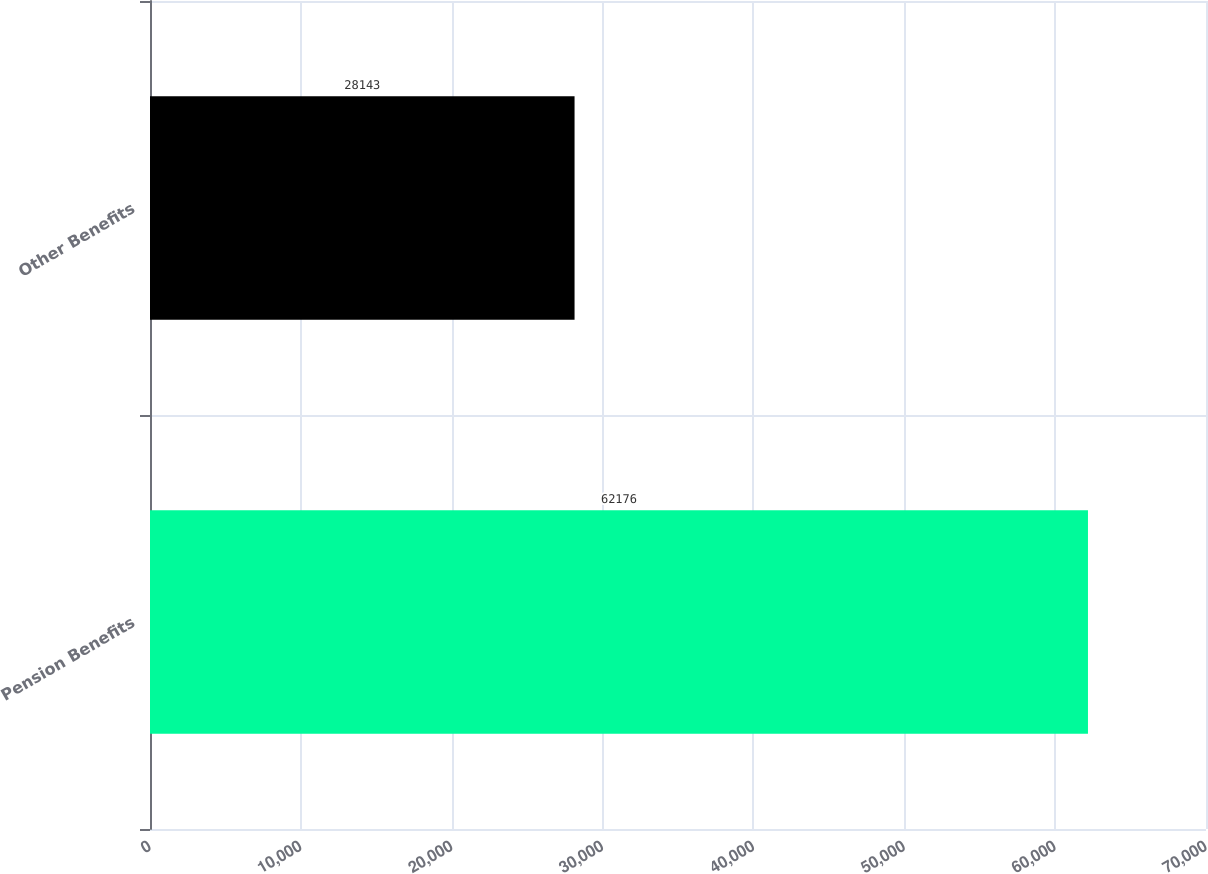<chart> <loc_0><loc_0><loc_500><loc_500><bar_chart><fcel>Pension Benefits<fcel>Other Benefits<nl><fcel>62176<fcel>28143<nl></chart> 